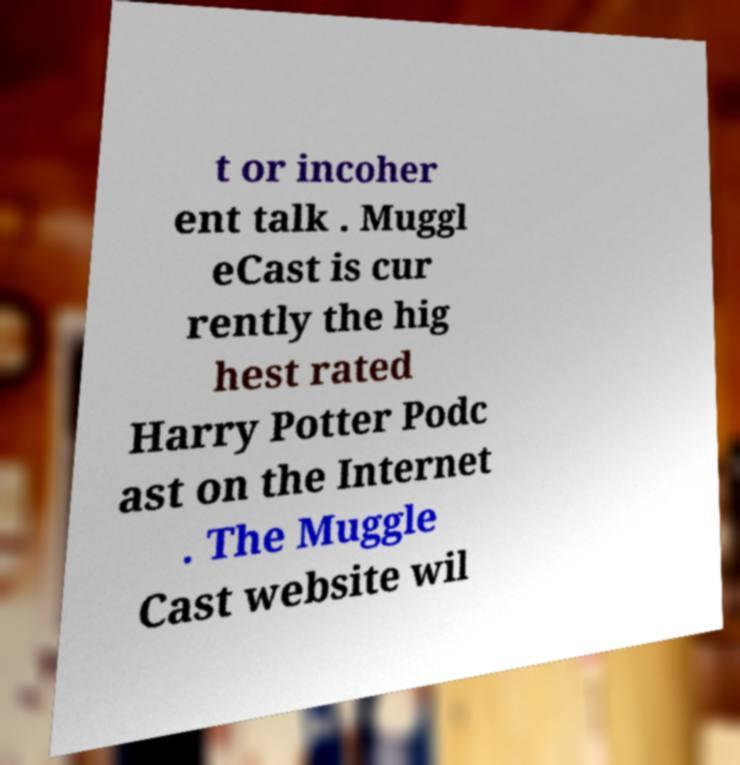For documentation purposes, I need the text within this image transcribed. Could you provide that? t or incoher ent talk . Muggl eCast is cur rently the hig hest rated Harry Potter Podc ast on the Internet . The Muggle Cast website wil 